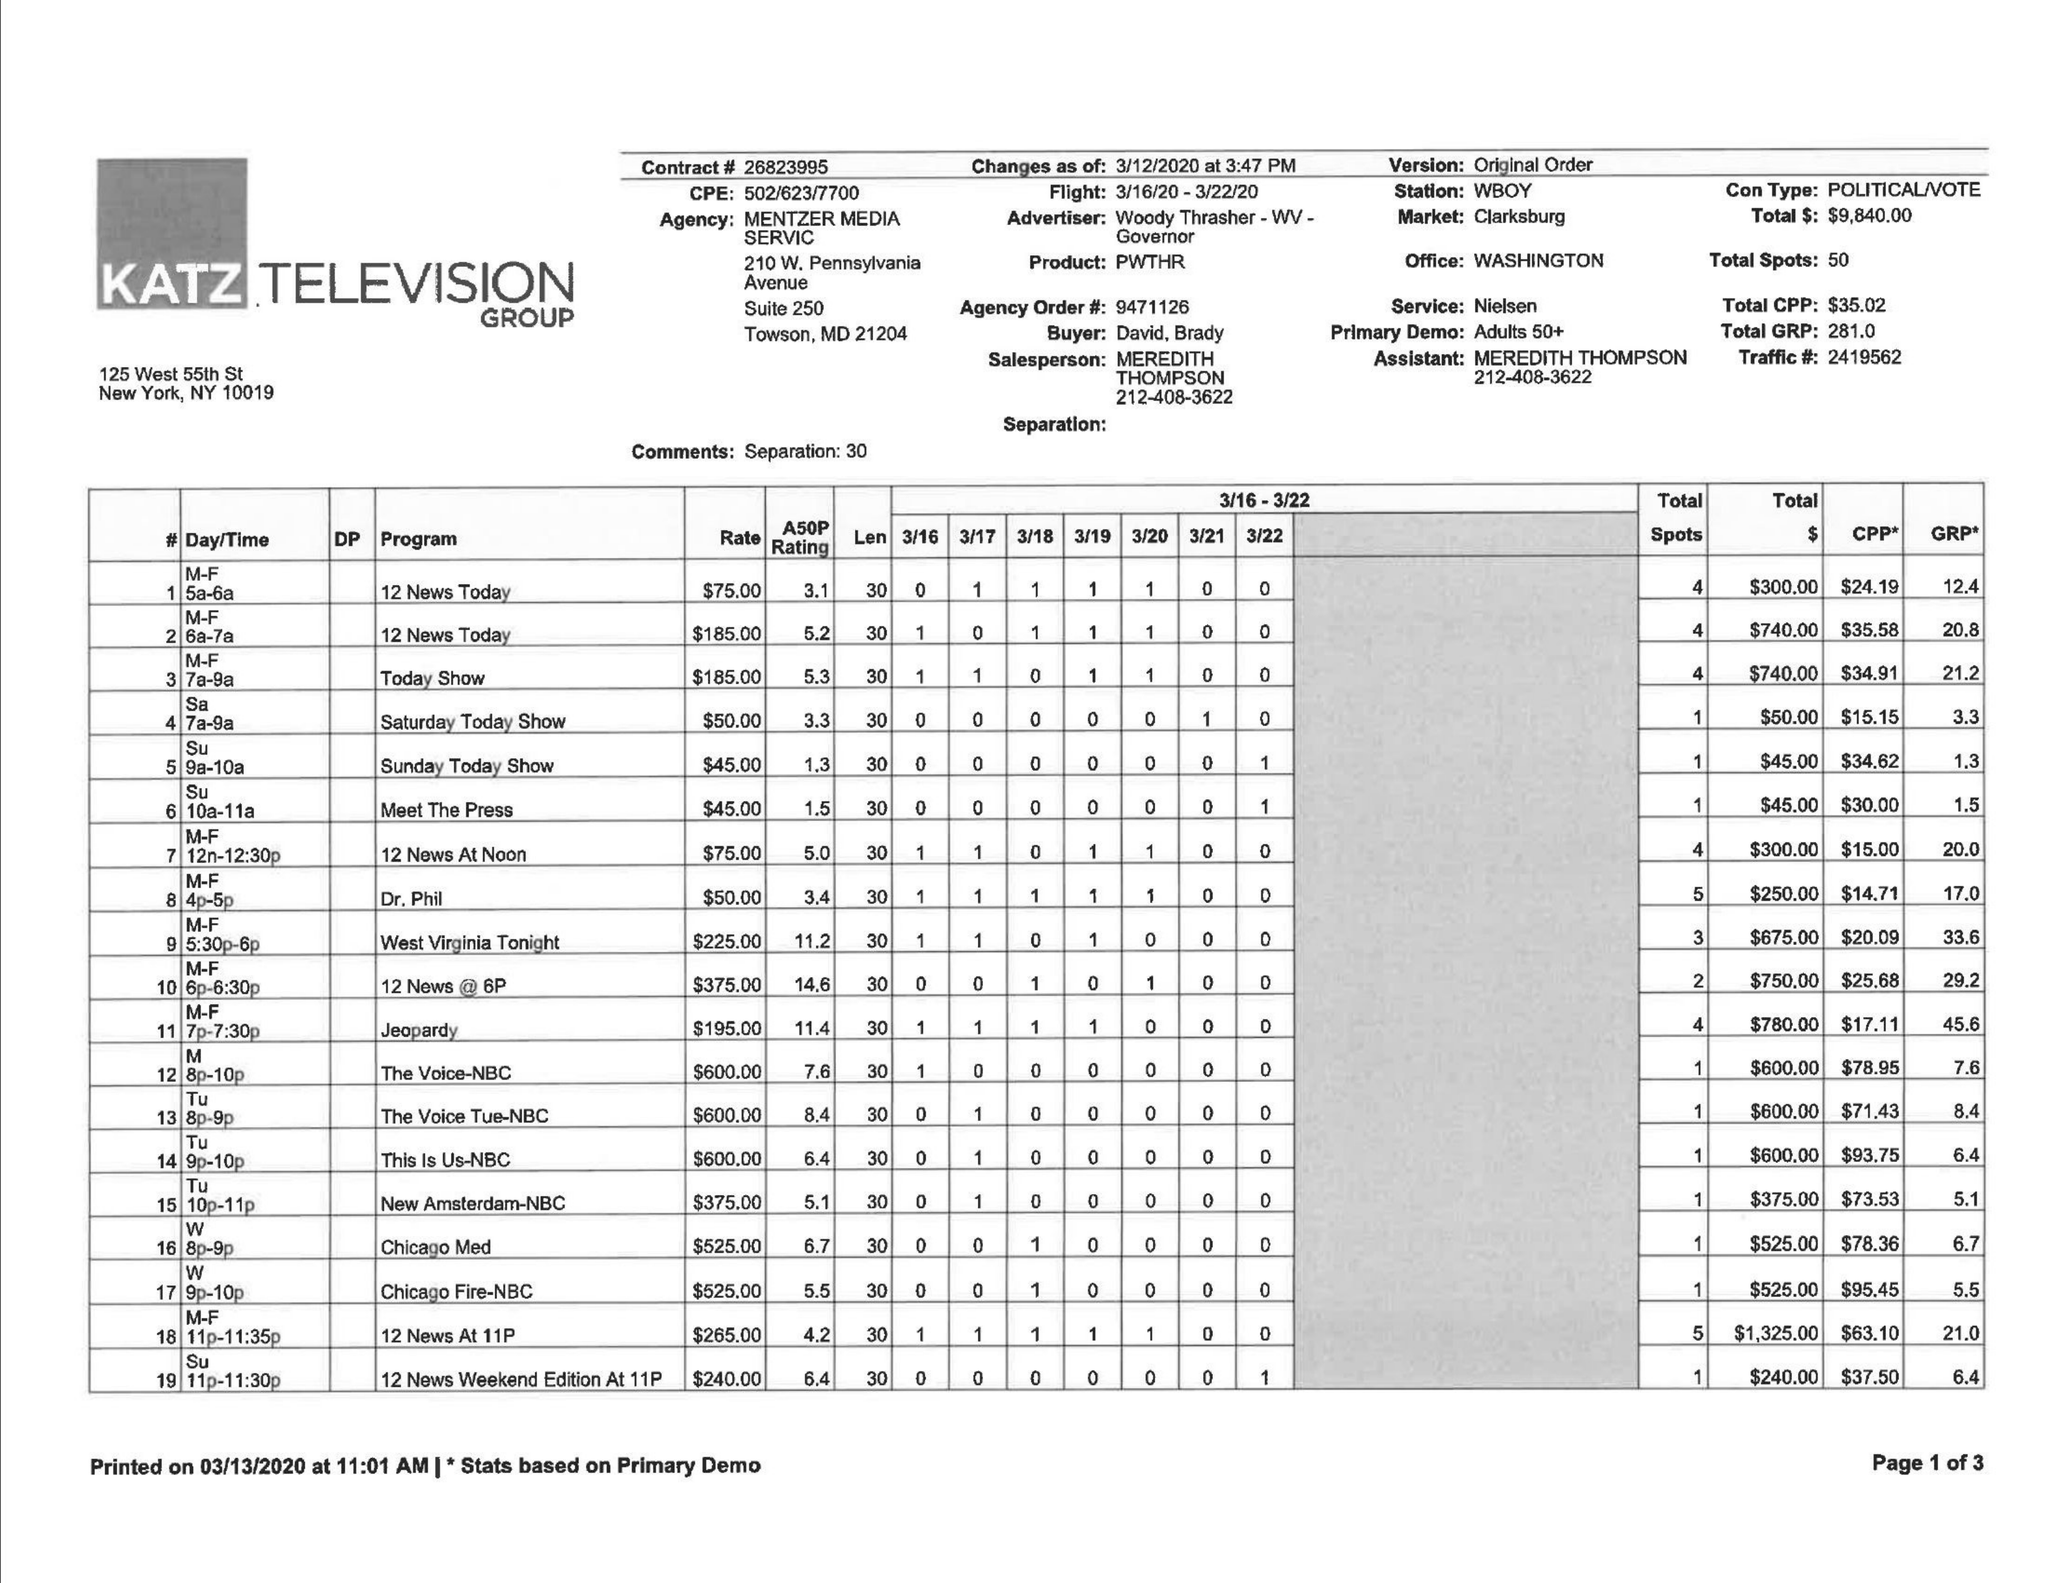What is the value for the contract_num?
Answer the question using a single word or phrase. None 